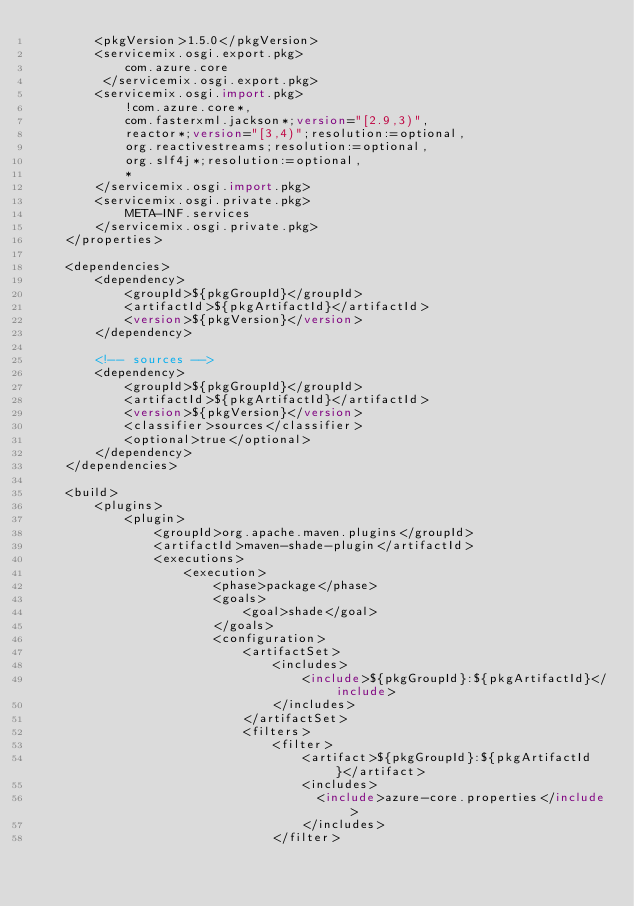<code> <loc_0><loc_0><loc_500><loc_500><_XML_>        <pkgVersion>1.5.0</pkgVersion>
        <servicemix.osgi.export.pkg>
            com.azure.core
         </servicemix.osgi.export.pkg>
        <servicemix.osgi.import.pkg>
            !com.azure.core*,
            com.fasterxml.jackson*;version="[2.9,3)",
            reactor*;version="[3,4)";resolution:=optional,
            org.reactivestreams;resolution:=optional,
            org.slf4j*;resolution:=optional,
            *
        </servicemix.osgi.import.pkg>
        <servicemix.osgi.private.pkg>
            META-INF.services
        </servicemix.osgi.private.pkg>
    </properties>

    <dependencies>
        <dependency>
            <groupId>${pkgGroupId}</groupId>
            <artifactId>${pkgArtifactId}</artifactId>
            <version>${pkgVersion}</version>
        </dependency>

        <!-- sources -->
        <dependency>
            <groupId>${pkgGroupId}</groupId>
            <artifactId>${pkgArtifactId}</artifactId>
            <version>${pkgVersion}</version>
            <classifier>sources</classifier>
            <optional>true</optional>
        </dependency>
    </dependencies>

    <build>
        <plugins>
            <plugin>
                <groupId>org.apache.maven.plugins</groupId>
                <artifactId>maven-shade-plugin</artifactId>
                <executions>
                    <execution>
                        <phase>package</phase>
                        <goals>
                            <goal>shade</goal>
                        </goals>
                        <configuration>
                            <artifactSet>
                                <includes>
                                    <include>${pkgGroupId}:${pkgArtifactId}</include>
                                </includes>
                            </artifactSet>
                            <filters>
                                <filter>
                                    <artifact>${pkgGroupId}:${pkgArtifactId}</artifact>
                                    <includes>
                                      <include>azure-core.properties</include>
                                    </includes>
                                </filter></code> 